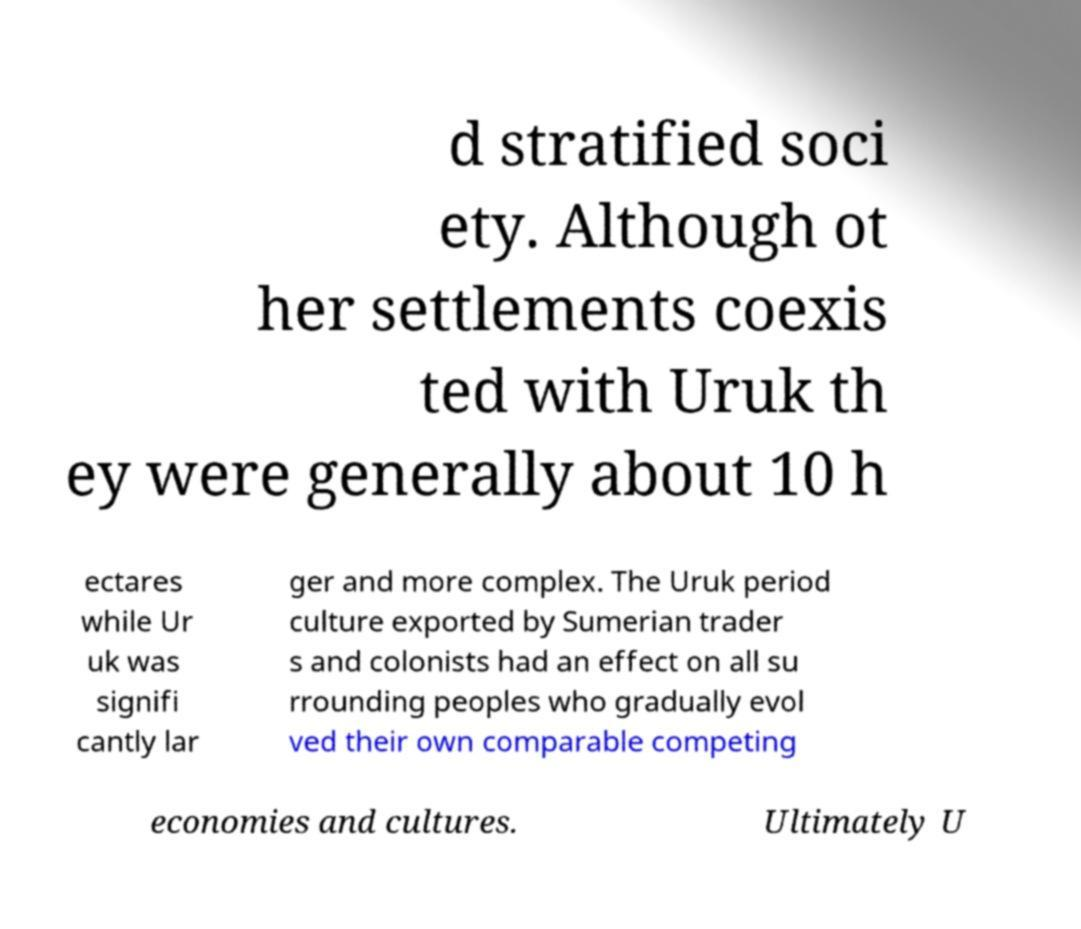For documentation purposes, I need the text within this image transcribed. Could you provide that? d stratified soci ety. Although ot her settlements coexis ted with Uruk th ey were generally about 10 h ectares while Ur uk was signifi cantly lar ger and more complex. The Uruk period culture exported by Sumerian trader s and colonists had an effect on all su rrounding peoples who gradually evol ved their own comparable competing economies and cultures. Ultimately U 